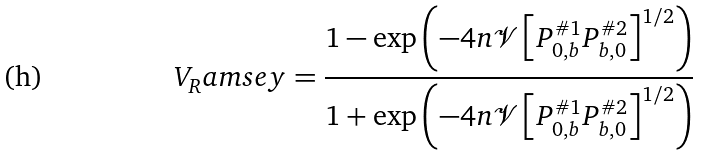<formula> <loc_0><loc_0><loc_500><loc_500>V _ { R } a m s e y = \frac { 1 - \exp \left ( - 4 n \mathcal { V } \left [ P _ { 0 , b } ^ { \# 1 } P _ { b , 0 } ^ { \# 2 } \right ] ^ { 1 / 2 } \right ) } { 1 + \exp \left ( - 4 n \mathcal { V } \left [ P _ { 0 , b } ^ { \# 1 } P _ { b , 0 } ^ { \# 2 } \right ] ^ { 1 / 2 } \right ) }</formula> 